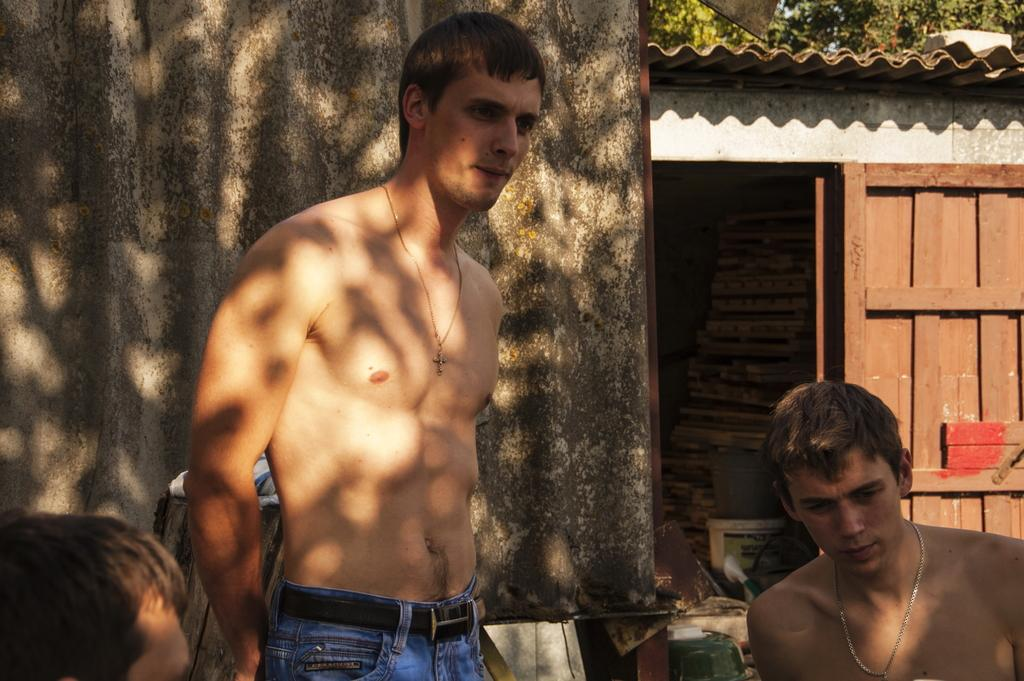What can be observed about the attire of the persons in the image? The persons in the image are partially naked. What can be seen in the background of the image? There is a wall, a door, and trees in the background of the image. What type of produce can be seen growing near the river in the image? There is no produce or river present in the image. What tool is being used by the persons in the image to build the wall? There is no tool, such as a hammer, visible in the image. 